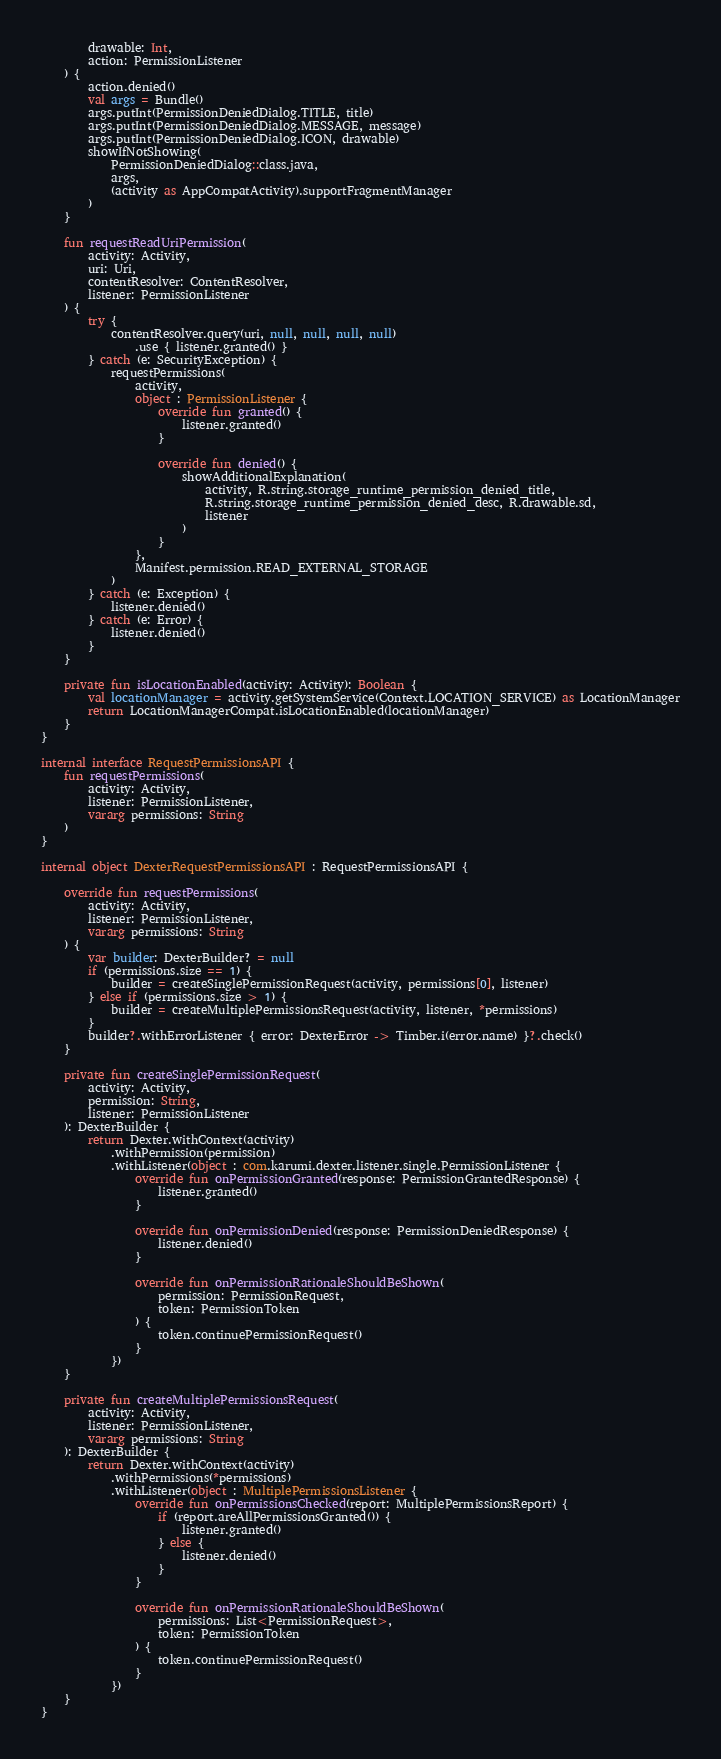Convert code to text. <code><loc_0><loc_0><loc_500><loc_500><_Kotlin_>        drawable: Int,
        action: PermissionListener
    ) {
        action.denied()
        val args = Bundle()
        args.putInt(PermissionDeniedDialog.TITLE, title)
        args.putInt(PermissionDeniedDialog.MESSAGE, message)
        args.putInt(PermissionDeniedDialog.ICON, drawable)
        showIfNotShowing(
            PermissionDeniedDialog::class.java,
            args,
            (activity as AppCompatActivity).supportFragmentManager
        )
    }

    fun requestReadUriPermission(
        activity: Activity,
        uri: Uri,
        contentResolver: ContentResolver,
        listener: PermissionListener
    ) {
        try {
            contentResolver.query(uri, null, null, null, null)
                .use { listener.granted() }
        } catch (e: SecurityException) {
            requestPermissions(
                activity,
                object : PermissionListener {
                    override fun granted() {
                        listener.granted()
                    }

                    override fun denied() {
                        showAdditionalExplanation(
                            activity, R.string.storage_runtime_permission_denied_title,
                            R.string.storage_runtime_permission_denied_desc, R.drawable.sd,
                            listener
                        )
                    }
                },
                Manifest.permission.READ_EXTERNAL_STORAGE
            )
        } catch (e: Exception) {
            listener.denied()
        } catch (e: Error) {
            listener.denied()
        }
    }

    private fun isLocationEnabled(activity: Activity): Boolean {
        val locationManager = activity.getSystemService(Context.LOCATION_SERVICE) as LocationManager
        return LocationManagerCompat.isLocationEnabled(locationManager)
    }
}

internal interface RequestPermissionsAPI {
    fun requestPermissions(
        activity: Activity,
        listener: PermissionListener,
        vararg permissions: String
    )
}

internal object DexterRequestPermissionsAPI : RequestPermissionsAPI {

    override fun requestPermissions(
        activity: Activity,
        listener: PermissionListener,
        vararg permissions: String
    ) {
        var builder: DexterBuilder? = null
        if (permissions.size == 1) {
            builder = createSinglePermissionRequest(activity, permissions[0], listener)
        } else if (permissions.size > 1) {
            builder = createMultiplePermissionsRequest(activity, listener, *permissions)
        }
        builder?.withErrorListener { error: DexterError -> Timber.i(error.name) }?.check()
    }

    private fun createSinglePermissionRequest(
        activity: Activity,
        permission: String,
        listener: PermissionListener
    ): DexterBuilder {
        return Dexter.withContext(activity)
            .withPermission(permission)
            .withListener(object : com.karumi.dexter.listener.single.PermissionListener {
                override fun onPermissionGranted(response: PermissionGrantedResponse) {
                    listener.granted()
                }

                override fun onPermissionDenied(response: PermissionDeniedResponse) {
                    listener.denied()
                }

                override fun onPermissionRationaleShouldBeShown(
                    permission: PermissionRequest,
                    token: PermissionToken
                ) {
                    token.continuePermissionRequest()
                }
            })
    }

    private fun createMultiplePermissionsRequest(
        activity: Activity,
        listener: PermissionListener,
        vararg permissions: String
    ): DexterBuilder {
        return Dexter.withContext(activity)
            .withPermissions(*permissions)
            .withListener(object : MultiplePermissionsListener {
                override fun onPermissionsChecked(report: MultiplePermissionsReport) {
                    if (report.areAllPermissionsGranted()) {
                        listener.granted()
                    } else {
                        listener.denied()
                    }
                }

                override fun onPermissionRationaleShouldBeShown(
                    permissions: List<PermissionRequest>,
                    token: PermissionToken
                ) {
                    token.continuePermissionRequest()
                }
            })
    }
}
</code> 